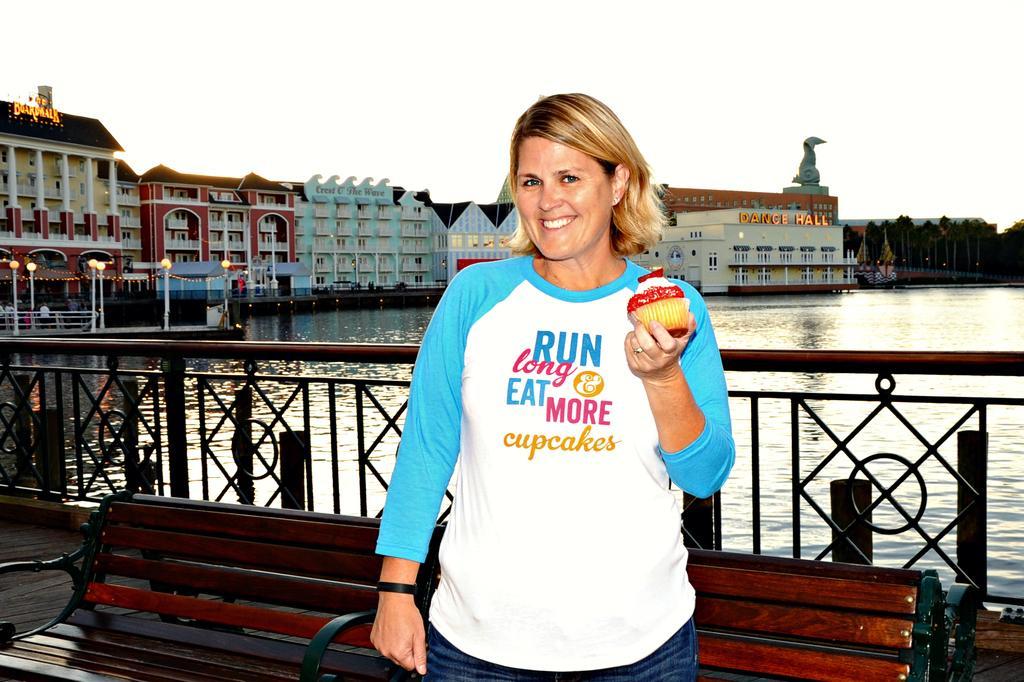In one or two sentences, can you explain what this image depicts? This woman wore t-shirt, holding smile and muffin. This is a freshwater river. Far there are trees and buildings. Backside of this woman there is a fence and bench. These are light poles. On this building there is a sculpture. 